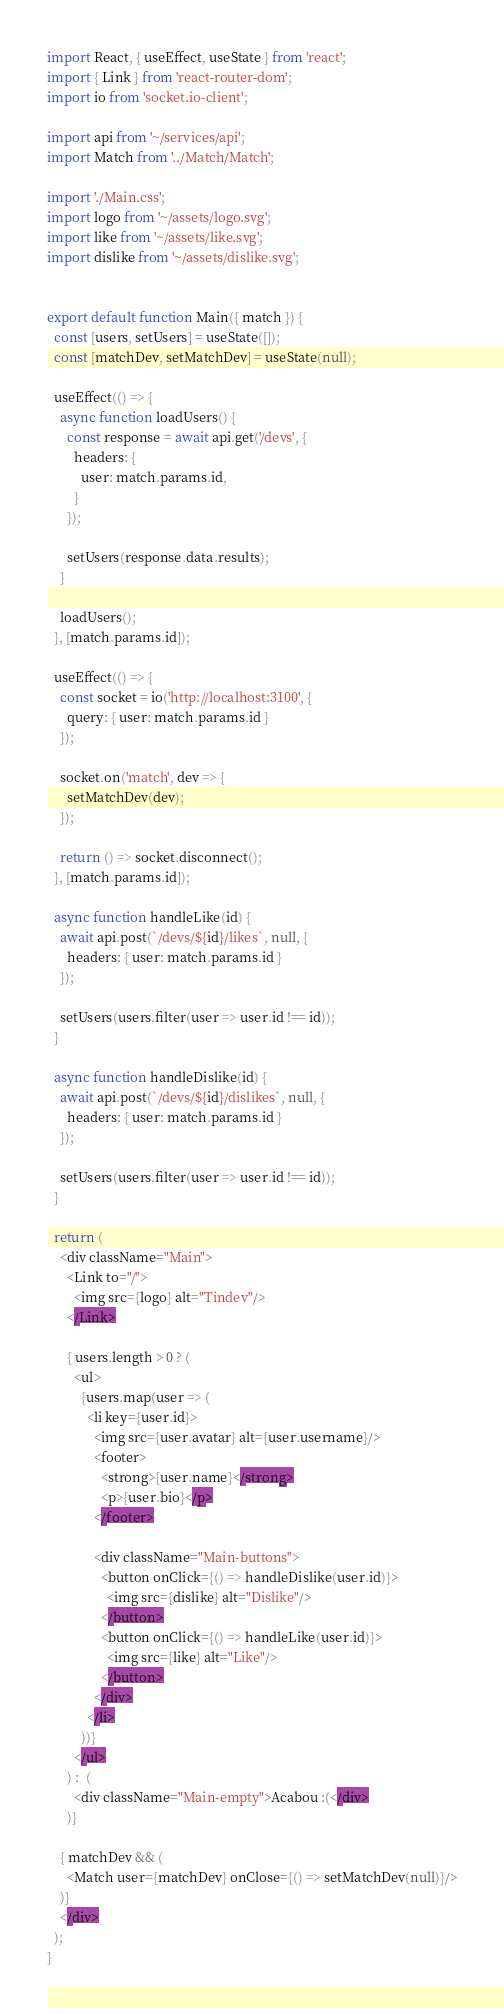Convert code to text. <code><loc_0><loc_0><loc_500><loc_500><_JavaScript_>import React, { useEffect, useState } from 'react';
import { Link } from 'react-router-dom';
import io from 'socket.io-client';

import api from '~/services/api';
import Match from '../Match/Match';

import './Main.css';
import logo from '~/assets/logo.svg';
import like from '~/assets/like.svg';
import dislike from '~/assets/dislike.svg';


export default function Main({ match }) {
  const [users, setUsers] = useState([]);
  const [matchDev, setMatchDev] = useState(null);
  
  useEffect(() => {
    async function loadUsers() {
      const response = await api.get('/devs', {
        headers: {
          user: match.params.id,
        }
      });
      
      setUsers(response.data.results);
    }
    
    loadUsers();
  }, [match.params.id]);
  
  useEffect(() => {
    const socket = io('http://localhost:3100', {
      query: { user: match.params.id }
    });

    socket.on('match', dev => {
      setMatchDev(dev);
    });

    return () => socket.disconnect();
  }, [match.params.id]);

  async function handleLike(id) {
    await api.post(`/devs/${id}/likes`, null, {
      headers: { user: match.params.id }
    });

    setUsers(users.filter(user => user.id !== id));
  }

  async function handleDislike(id) {
    await api.post(`/devs/${id}/dislikes`, null, {
      headers: { user: match.params.id }
    });

    setUsers(users.filter(user => user.id !== id));
  }

  return (
    <div className="Main">
      <Link to="/">
        <img src={logo} alt="Tindev"/>
      </Link>

      { users.length > 0 ? (
        <ul>
          {users.map(user => (
            <li key={user.id}>
              <img src={user.avatar} alt={user.username}/>
              <footer>
                <strong>{user.name}</strong>
                <p>{user.bio}</p>
              </footer>

              <div className="Main-buttons">
                <button onClick={() => handleDislike(user.id)}>
                  <img src={dislike} alt="Dislike"/>
                </button>
                <button onClick={() => handleLike(user.id)}>
                  <img src={like} alt="Like"/>
                </button>
              </div>
            </li>
          ))}
        </ul>
      ) :  (
        <div className="Main-empty">Acabou :(</div>
      )}
    
    { matchDev && (
      <Match user={matchDev} onClose={() => setMatchDev(null)}/>
    )}
    </div>
  );
}</code> 